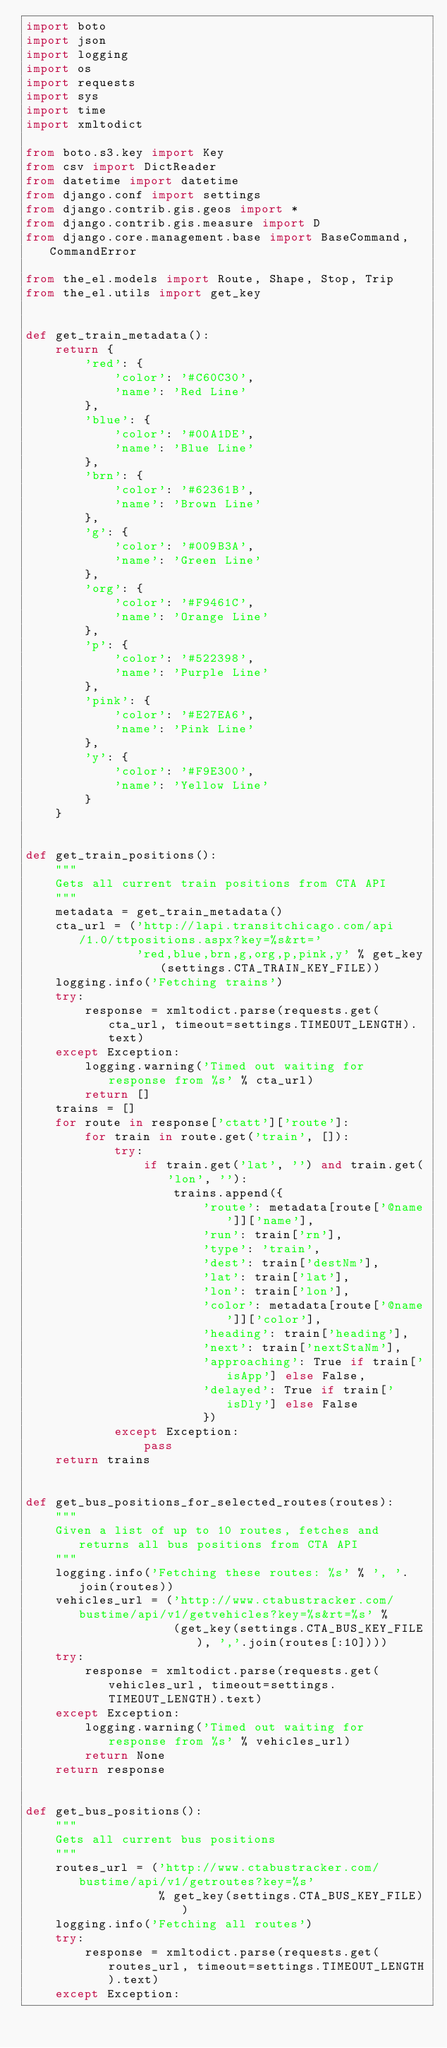Convert code to text. <code><loc_0><loc_0><loc_500><loc_500><_Python_>import boto
import json
import logging
import os
import requests
import sys
import time
import xmltodict

from boto.s3.key import Key
from csv import DictReader
from datetime import datetime
from django.conf import settings
from django.contrib.gis.geos import *
from django.contrib.gis.measure import D
from django.core.management.base import BaseCommand, CommandError

from the_el.models import Route, Shape, Stop, Trip
from the_el.utils import get_key


def get_train_metadata():
    return {
        'red': {
            'color': '#C60C30',
            'name': 'Red Line'
        },
        'blue': {
            'color': '#00A1DE',
            'name': 'Blue Line'
        },
        'brn': {
            'color': '#62361B',
            'name': 'Brown Line'
        },
        'g': {
            'color': '#009B3A',
            'name': 'Green Line'
        },
        'org': {
            'color': '#F9461C',
            'name': 'Orange Line'
        },
        'p': {
            'color': '#522398',
            'name': 'Purple Line'
        },
        'pink': {
            'color': '#E27EA6',
            'name': 'Pink Line'
        },
        'y': {
            'color': '#F9E300',
            'name': 'Yellow Line'
        }
    }


def get_train_positions():
    """
    Gets all current train positions from CTA API
    """
    metadata = get_train_metadata()
    cta_url = ('http://lapi.transitchicago.com/api/1.0/ttpositions.aspx?key=%s&rt='
               'red,blue,brn,g,org,p,pink,y' % get_key(settings.CTA_TRAIN_KEY_FILE))
    logging.info('Fetching trains')
    try:
        response = xmltodict.parse(requests.get(cta_url, timeout=settings.TIMEOUT_LENGTH).text)
    except Exception:
        logging.warning('Timed out waiting for response from %s' % cta_url)
        return []
    trains = []
    for route in response['ctatt']['route']:
        for train in route.get('train', []):
            try:
                if train.get('lat', '') and train.get('lon', ''):
                    trains.append({
                        'route': metadata[route['@name']]['name'],
                        'run': train['rn'],
                        'type': 'train',
                        'dest': train['destNm'],
                        'lat': train['lat'],
                        'lon': train['lon'],
                        'color': metadata[route['@name']]['color'],
                        'heading': train['heading'],
                        'next': train['nextStaNm'],
                        'approaching': True if train['isApp'] else False,
                        'delayed': True if train['isDly'] else False
                        })
            except Exception:
                pass
    return trains


def get_bus_positions_for_selected_routes(routes):
    """
    Given a list of up to 10 routes, fetches and returns all bus positions from CTA API
    """
    logging.info('Fetching these routes: %s' % ', '.join(routes))
    vehicles_url = ('http://www.ctabustracker.com/bustime/api/v1/getvehicles?key=%s&rt=%s' %
                    (get_key(settings.CTA_BUS_KEY_FILE), ','.join(routes[:10])))
    try:
        response = xmltodict.parse(requests.get(vehicles_url, timeout=settings.TIMEOUT_LENGTH).text)
    except Exception:
        logging.warning('Timed out waiting for response from %s' % vehicles_url)
        return None
    return response


def get_bus_positions():
    """
    Gets all current bus positions
    """
    routes_url = ('http://www.ctabustracker.com/bustime/api/v1/getroutes?key=%s'
                  % get_key(settings.CTA_BUS_KEY_FILE))
    logging.info('Fetching all routes')
    try:
        response = xmltodict.parse(requests.get(routes_url, timeout=settings.TIMEOUT_LENGTH).text)
    except Exception:</code> 